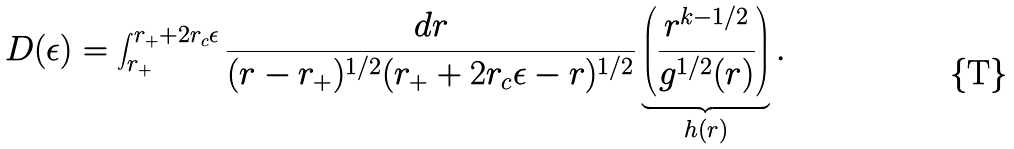<formula> <loc_0><loc_0><loc_500><loc_500>D ( \epsilon ) = \int _ { r _ { + } } ^ { r _ { + } + 2 r _ { c } \epsilon } \frac { d r } { ( r - r _ { + } ) ^ { 1 / 2 } ( r _ { + } + 2 r _ { c } \epsilon - r ) ^ { 1 / 2 } } \underbrace { \left ( \frac { r ^ { k - 1 / 2 } } { g ^ { 1 / 2 } ( r ) } \right ) } _ { h ( r ) } .</formula> 